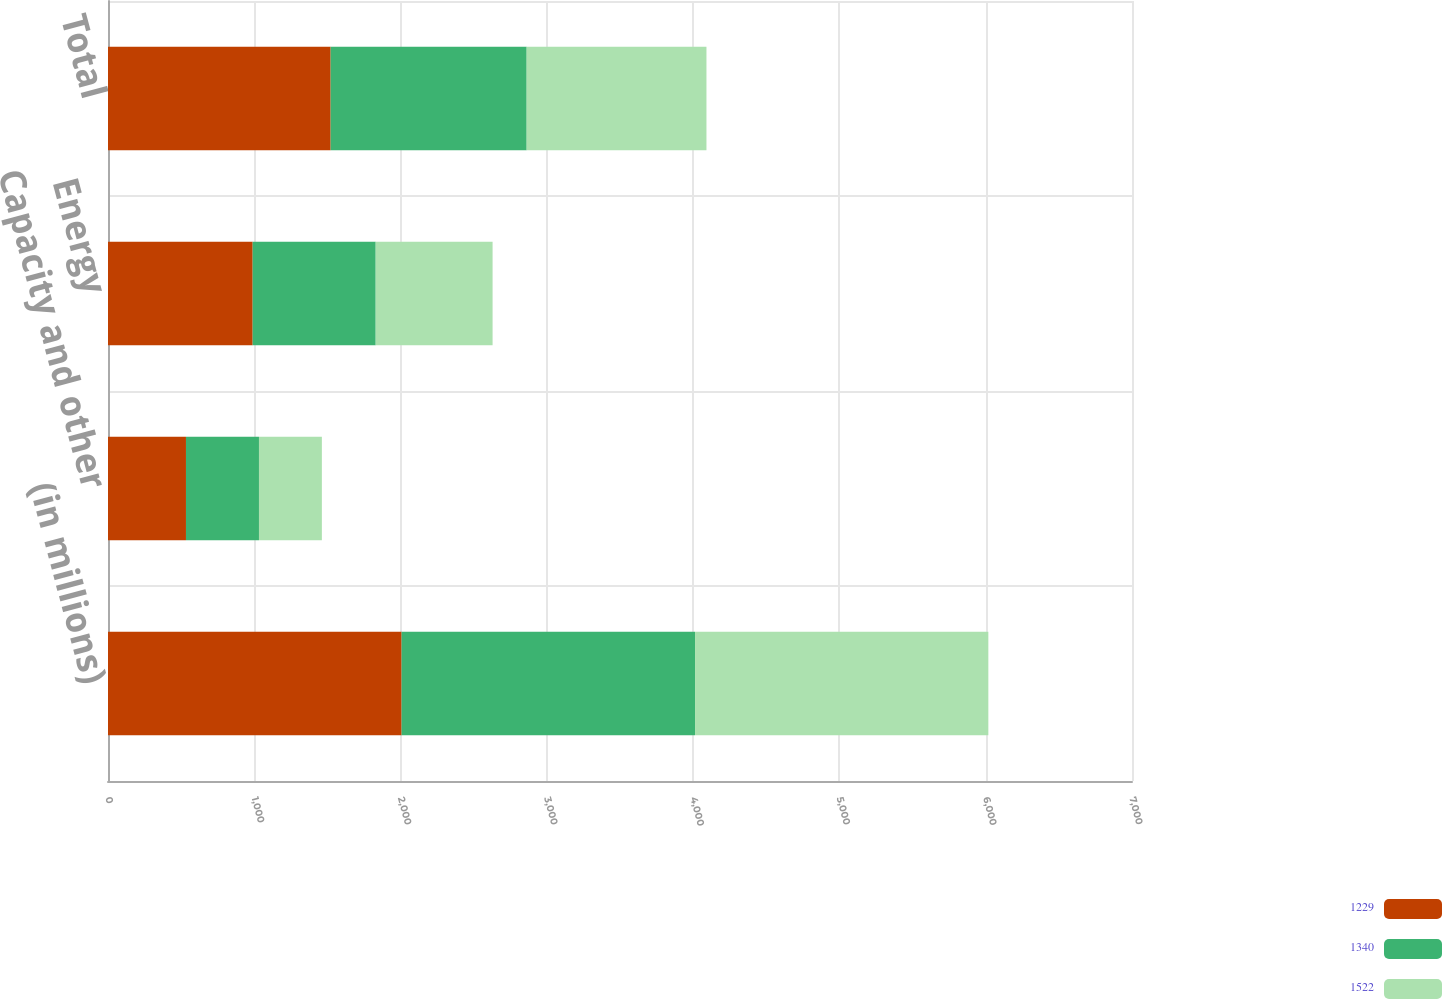Convert chart. <chart><loc_0><loc_0><loc_500><loc_500><stacked_bar_chart><ecel><fcel>(in millions)<fcel>Capacity and other<fcel>Energy<fcel>Total<nl><fcel>1229<fcel>2007<fcel>533<fcel>989<fcel>1522<nl><fcel>1340<fcel>2006<fcel>499<fcel>841<fcel>1340<nl><fcel>1522<fcel>2005<fcel>430<fcel>799<fcel>1229<nl></chart> 